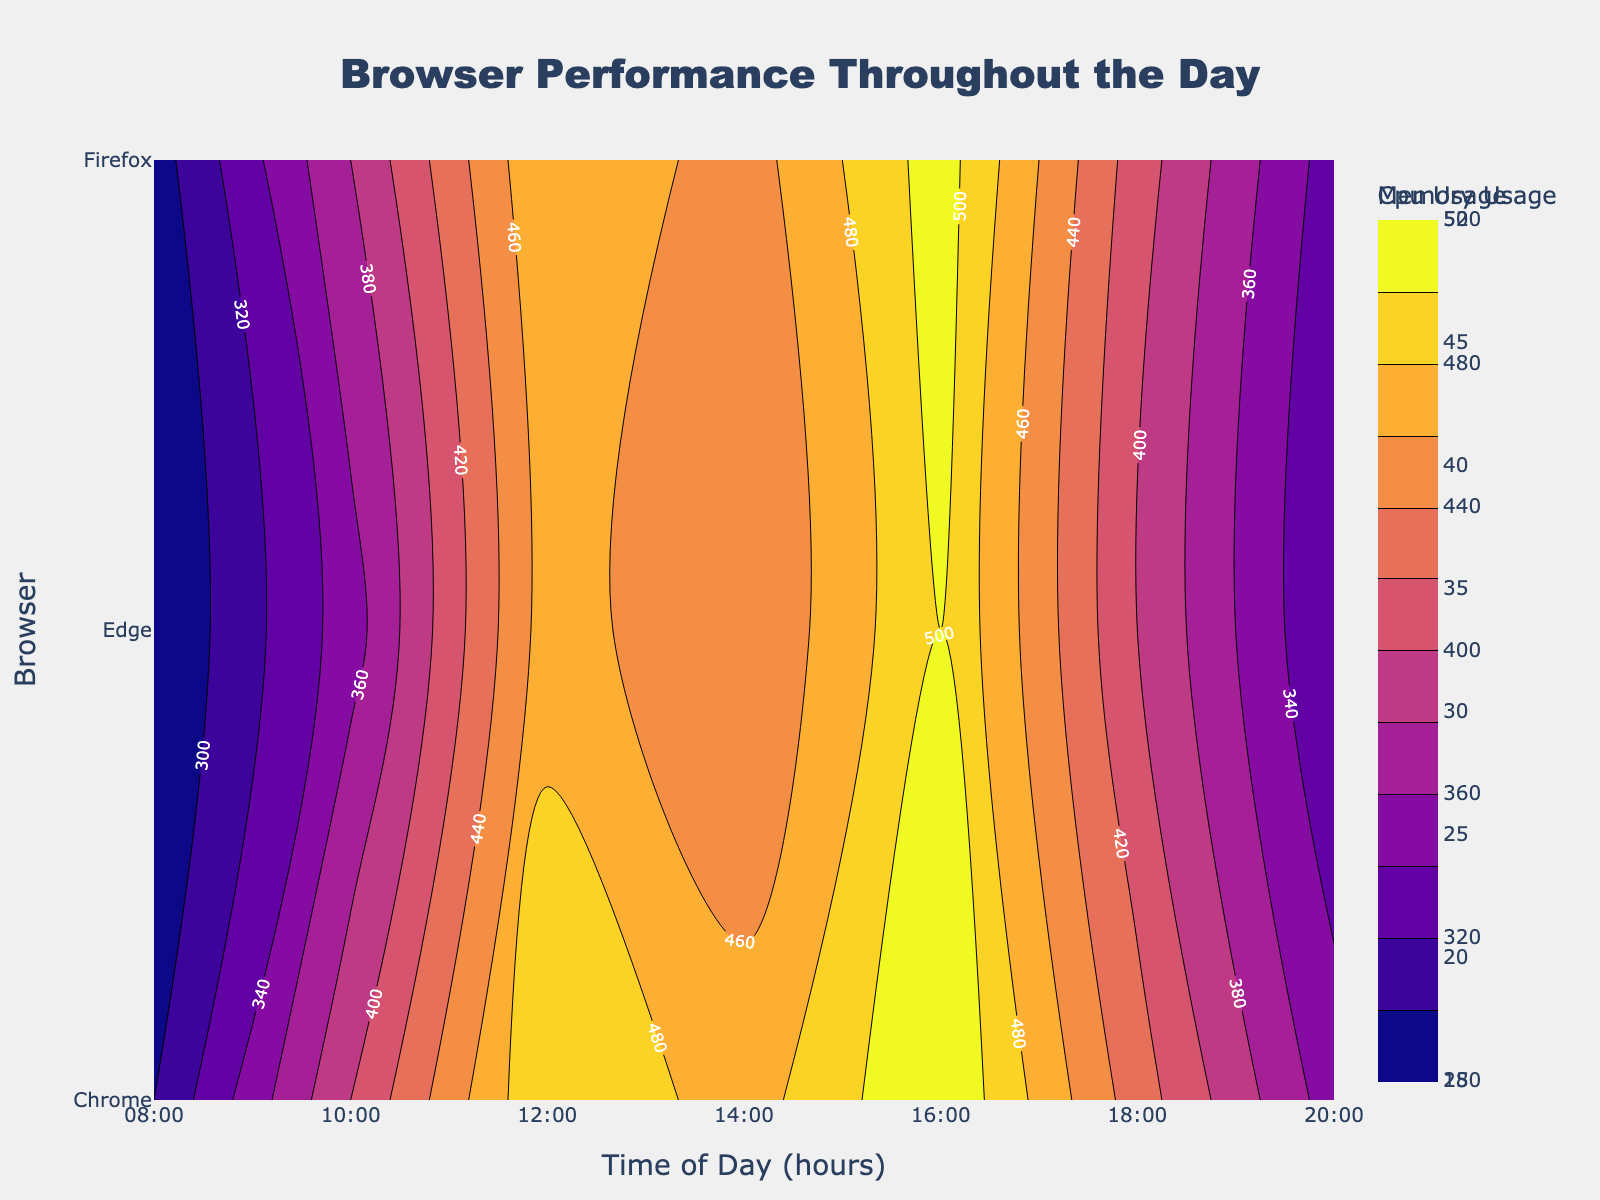What is the title of the plot? The plot title is located at the top center of the figure. It should be clearly labeled in a larger font.
Answer: Browser Performance Throughout the Day What metric does the color scale represent on the left side of the plot? There are color scales on both the left and right sides of the plot. The one on the left corresponds to "CPU Usage".
Answer: CPU Usage How many time points are shown on the x-axis? The x-axis represents the time of day. By counting the time ticks, we can see there are seven time points.
Answer: 7 Which browser shows the highest CPU usage at 16:00? We need to locate the 16:00 mark on the x-axis and identify the peak on the contour plot for CPU usage. Chrome shows the highest value.
Answer: Chrome Between 08:00 and 20:00, for which browser does memory usage exceed 500? We look at the contour for "Memory Usage" and identify the browser and time where the value exceeds 500. Chrome at 16:00 exceeds 500.
Answer: Chrome Which time of day shows a general decrease in CPU usage among all browsers? By visually inspecting the contour plot for "CPU Usage", we see all browsers' CPU usage decrease noticeably around 18:00.
Answer: 18:00 Comparing between 10:00 and 12:00, which browser has the smallest increase in memory usage? We compare the change in memory usage between 10:00 and 12:00 for each browser. Edge has the smallest increase.
Answer: Edge At 14:00, which browser uses less memory: Edge or Firefox? At 14:00, we compare the memory usage values for Edge and Firefox on the contour plot. Firefox uses less memory.
Answer: Firefox What is the general trend of CPU usage for Chrome throughout the day? By following the contour lines for Chrome's CPU usage from 08:00 to 20:00, we see an increase until 16:00, followed by a decrease.
Answer: Increase then decrease Is the highest memory usage recorded for Firefox at a higher time than the highest CPU usage for Edge? Identify the peak memory usage for Firefox and the peak CPU usage for Edge. Firefox's highest memory usage is at 16:00 and Edge's highest CPU usage is also at 16:00.
Answer: No 